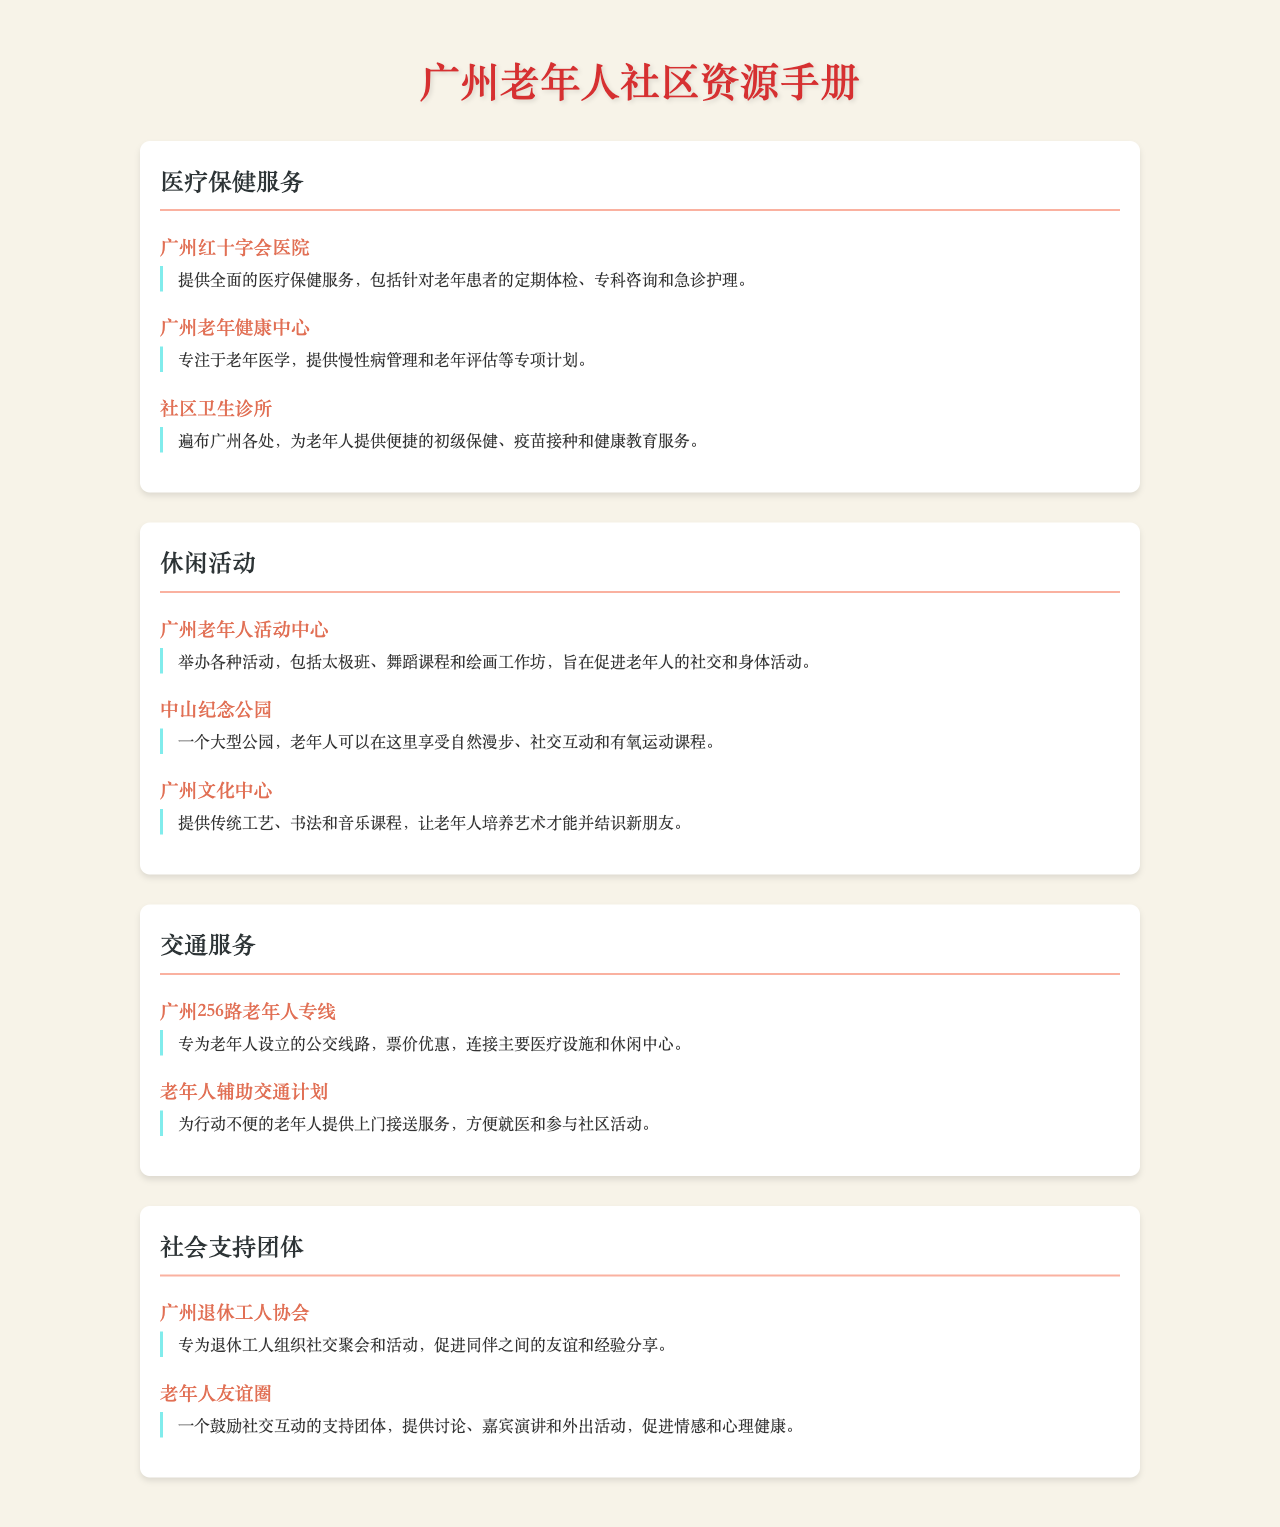什么医院提供老年患者定期体检？ 广州红十字会医院提供针对老年患者的定期体检。
Answer: 广州红十字会医院 哪个中心专注于老年医学？ 广州老年健康中心专注于老年医学。
Answer: 广州老年健康中心 广州老年人活动中心有哪些活动？ 广州老年人活动中心举办太极班、舞蹈课程和绘画工作坊。
Answer: 太极班、舞蹈课程和绘画工作坊 中山纪念公园适合老年人进行什么活动？ 中山纪念公园适合老年人享受自然漫步、社交互动和有氧运动课程。
Answer: 自然漫步、社交互动和有氧运动课程 广州256路老年人专线的主要功能是什么？ 广州256路老年人专线连接主要医疗设施和休闲中心。
Answer: 连接主要医疗设施和休闲中心 广州退休工人协会提供什么类型的活动？ 广州退休工人协会组织社交聚会和活动。
Answer: 社交聚会和活动 如何为行动不便的老年人提供帮助？ 老年人辅助交通计划为行动不便的老年人提供上门接送服务。
Answer: 上门接送服务 老年人友谊圈的主要目的是什么？ 老年人友谊圈促进社交互动和情感健康。
Answer: 促进社交互动和情感健康 